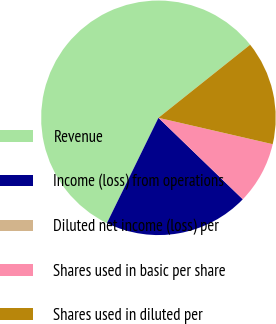Convert chart. <chart><loc_0><loc_0><loc_500><loc_500><pie_chart><fcel>Revenue<fcel>Income (loss) from operations<fcel>Diluted net income (loss) per<fcel>Shares used in basic per share<fcel>Shares used in diluted per<nl><fcel>57.05%<fcel>20.02%<fcel>0.0%<fcel>8.61%<fcel>14.32%<nl></chart> 